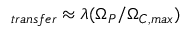<formula> <loc_0><loc_0><loc_500><loc_500>_ { t r a n s f e r } \approx \lambda ( \Omega _ { P } / \Omega _ { C , \max } )</formula> 